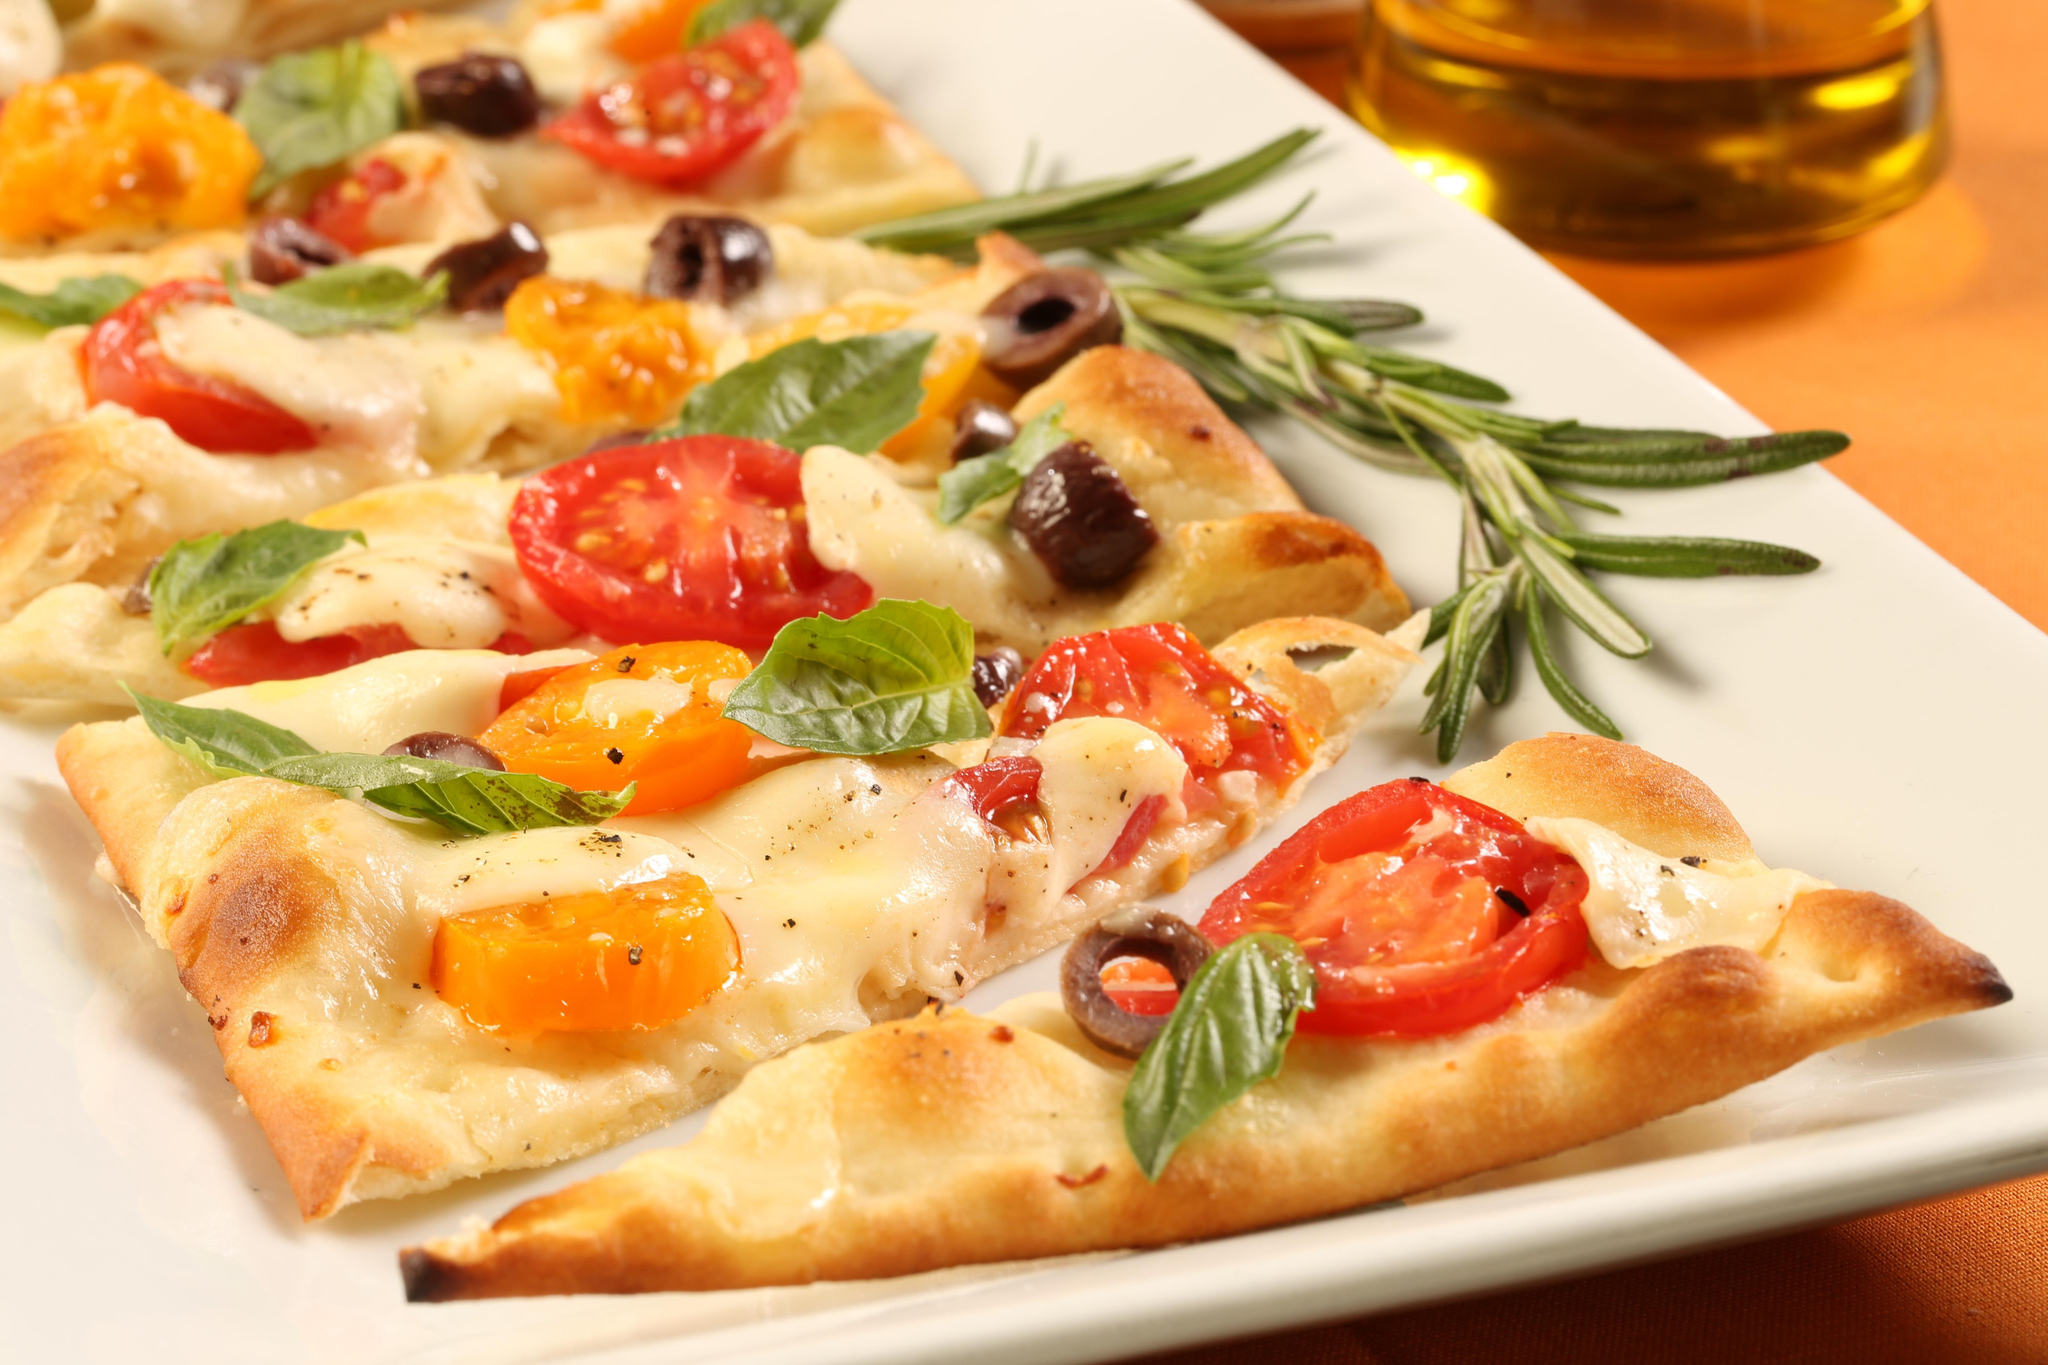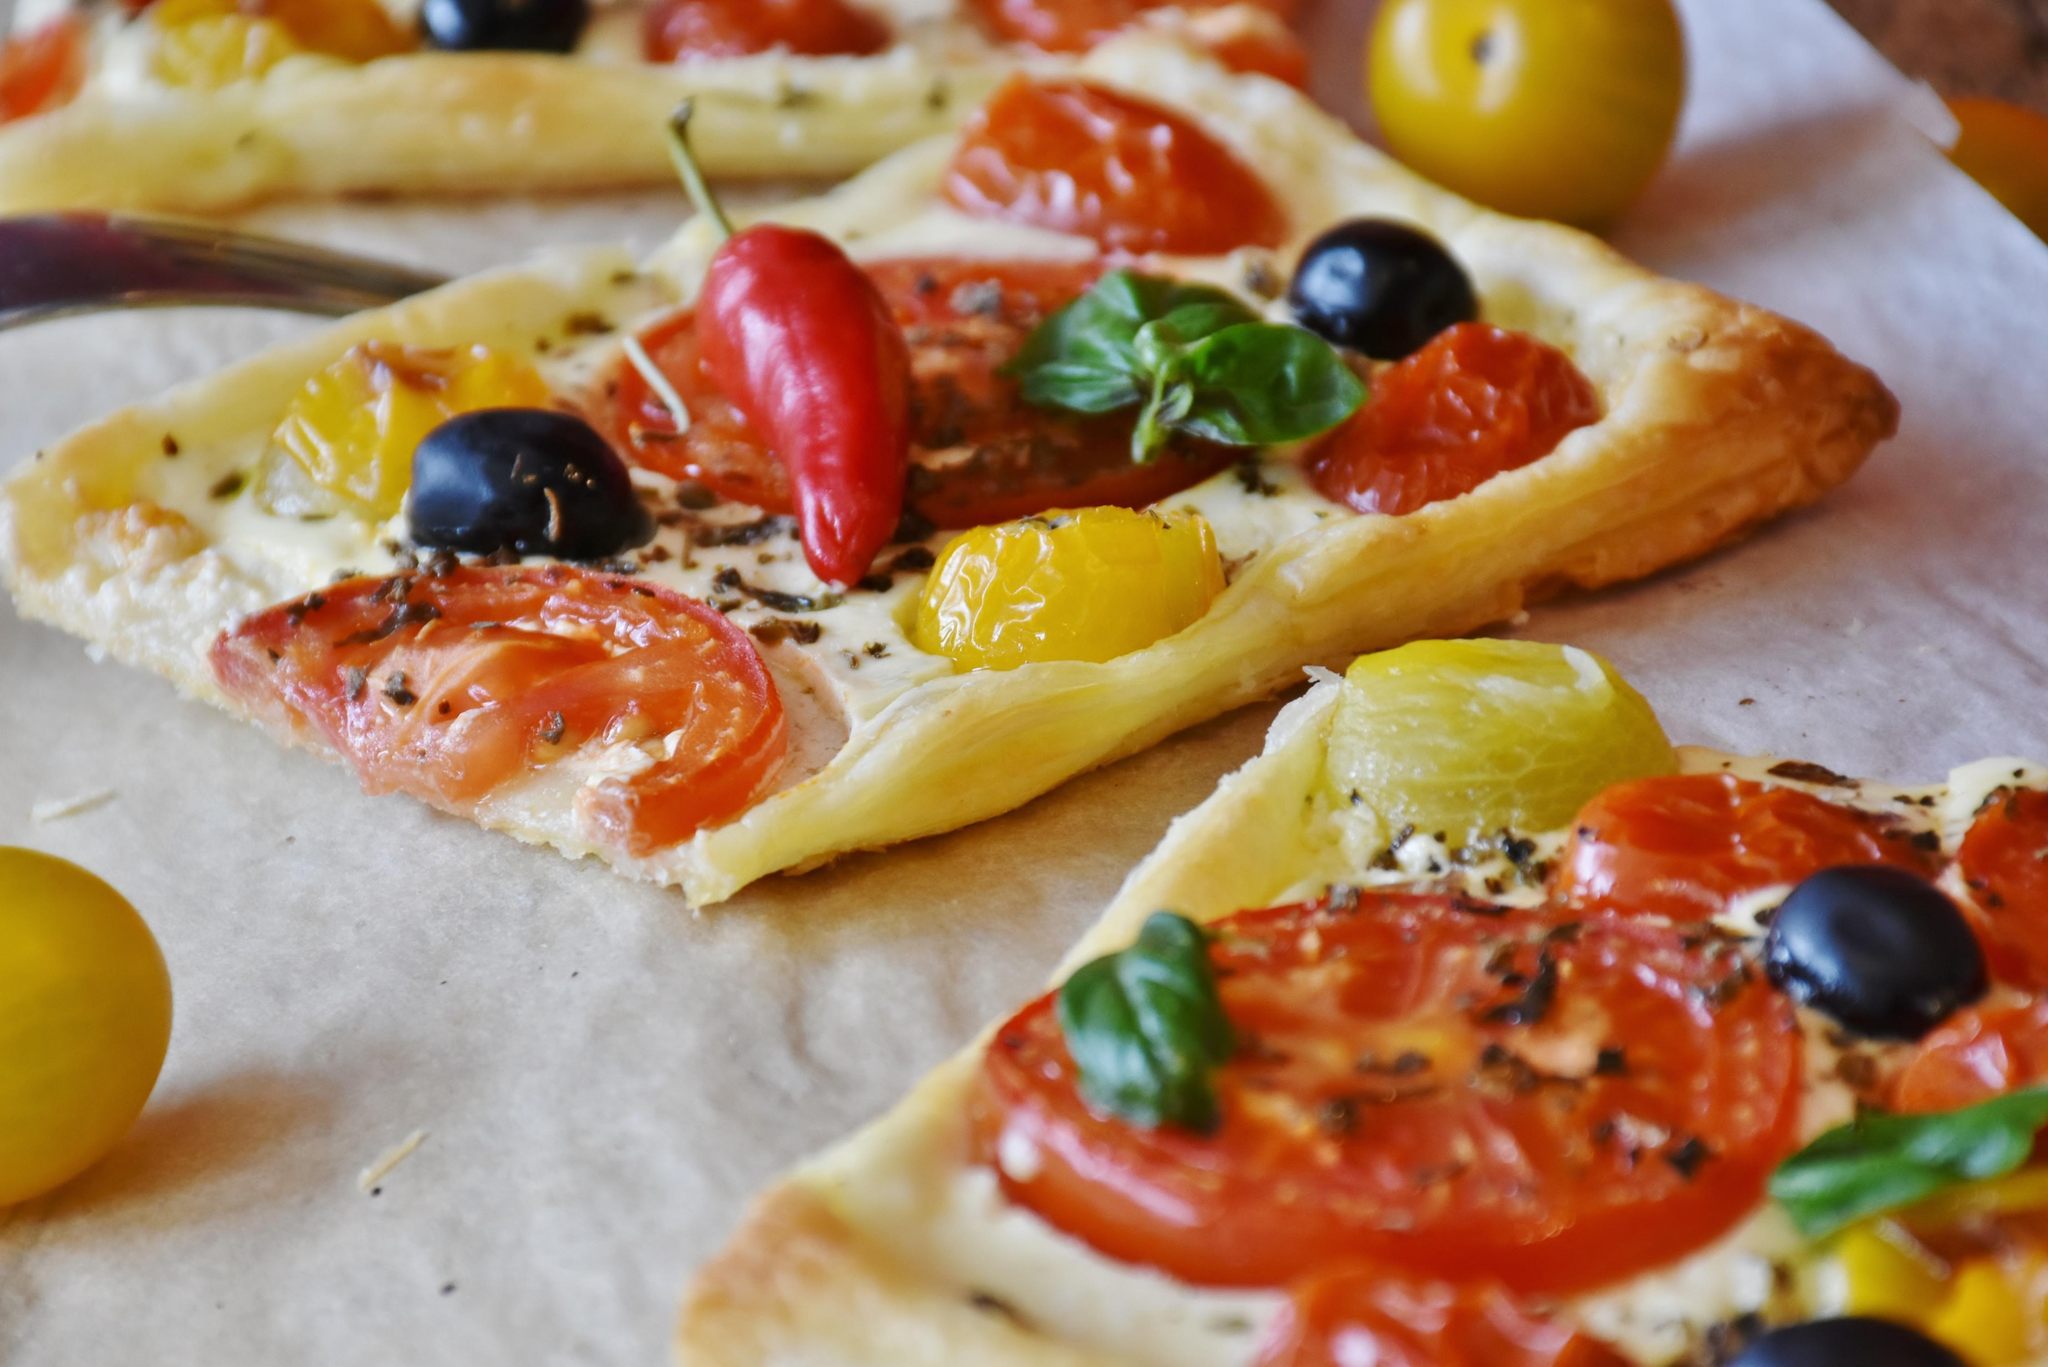The first image is the image on the left, the second image is the image on the right. Considering the images on both sides, is "All of the pizzas have been sliced." valid? Answer yes or no. Yes. 